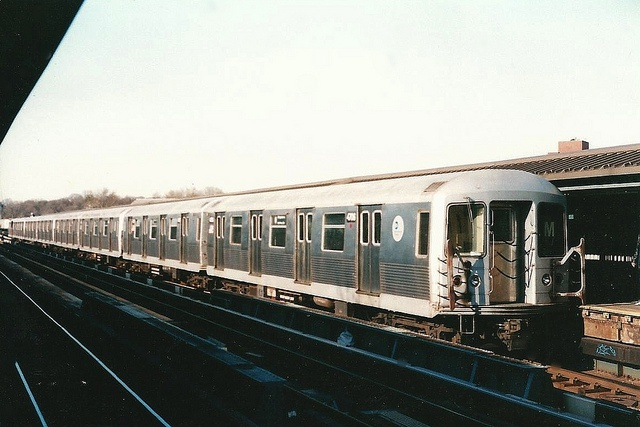Describe the objects in this image and their specific colors. I can see a train in gray, black, ivory, and darkgray tones in this image. 